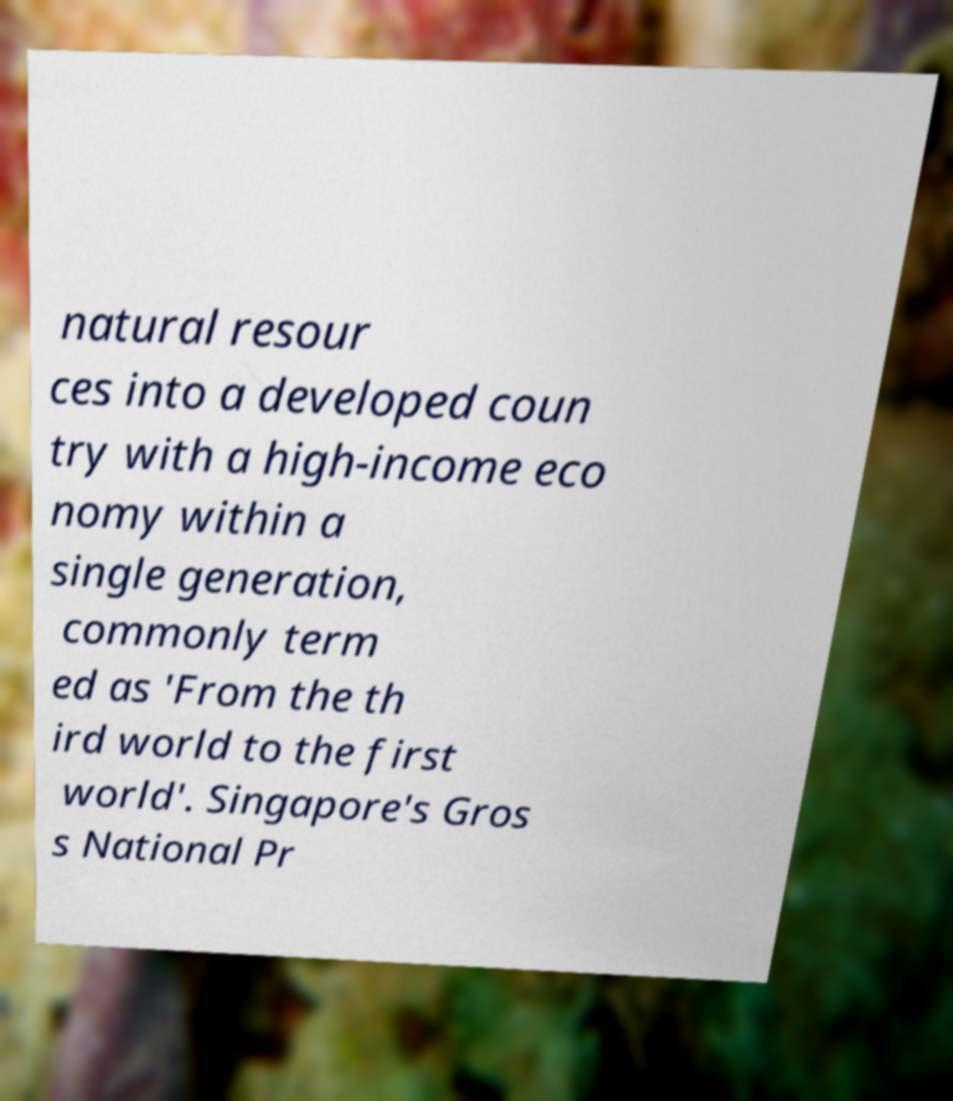Please read and relay the text visible in this image. What does it say? natural resour ces into a developed coun try with a high-income eco nomy within a single generation, commonly term ed as 'From the th ird world to the first world'. Singapore's Gros s National Pr 